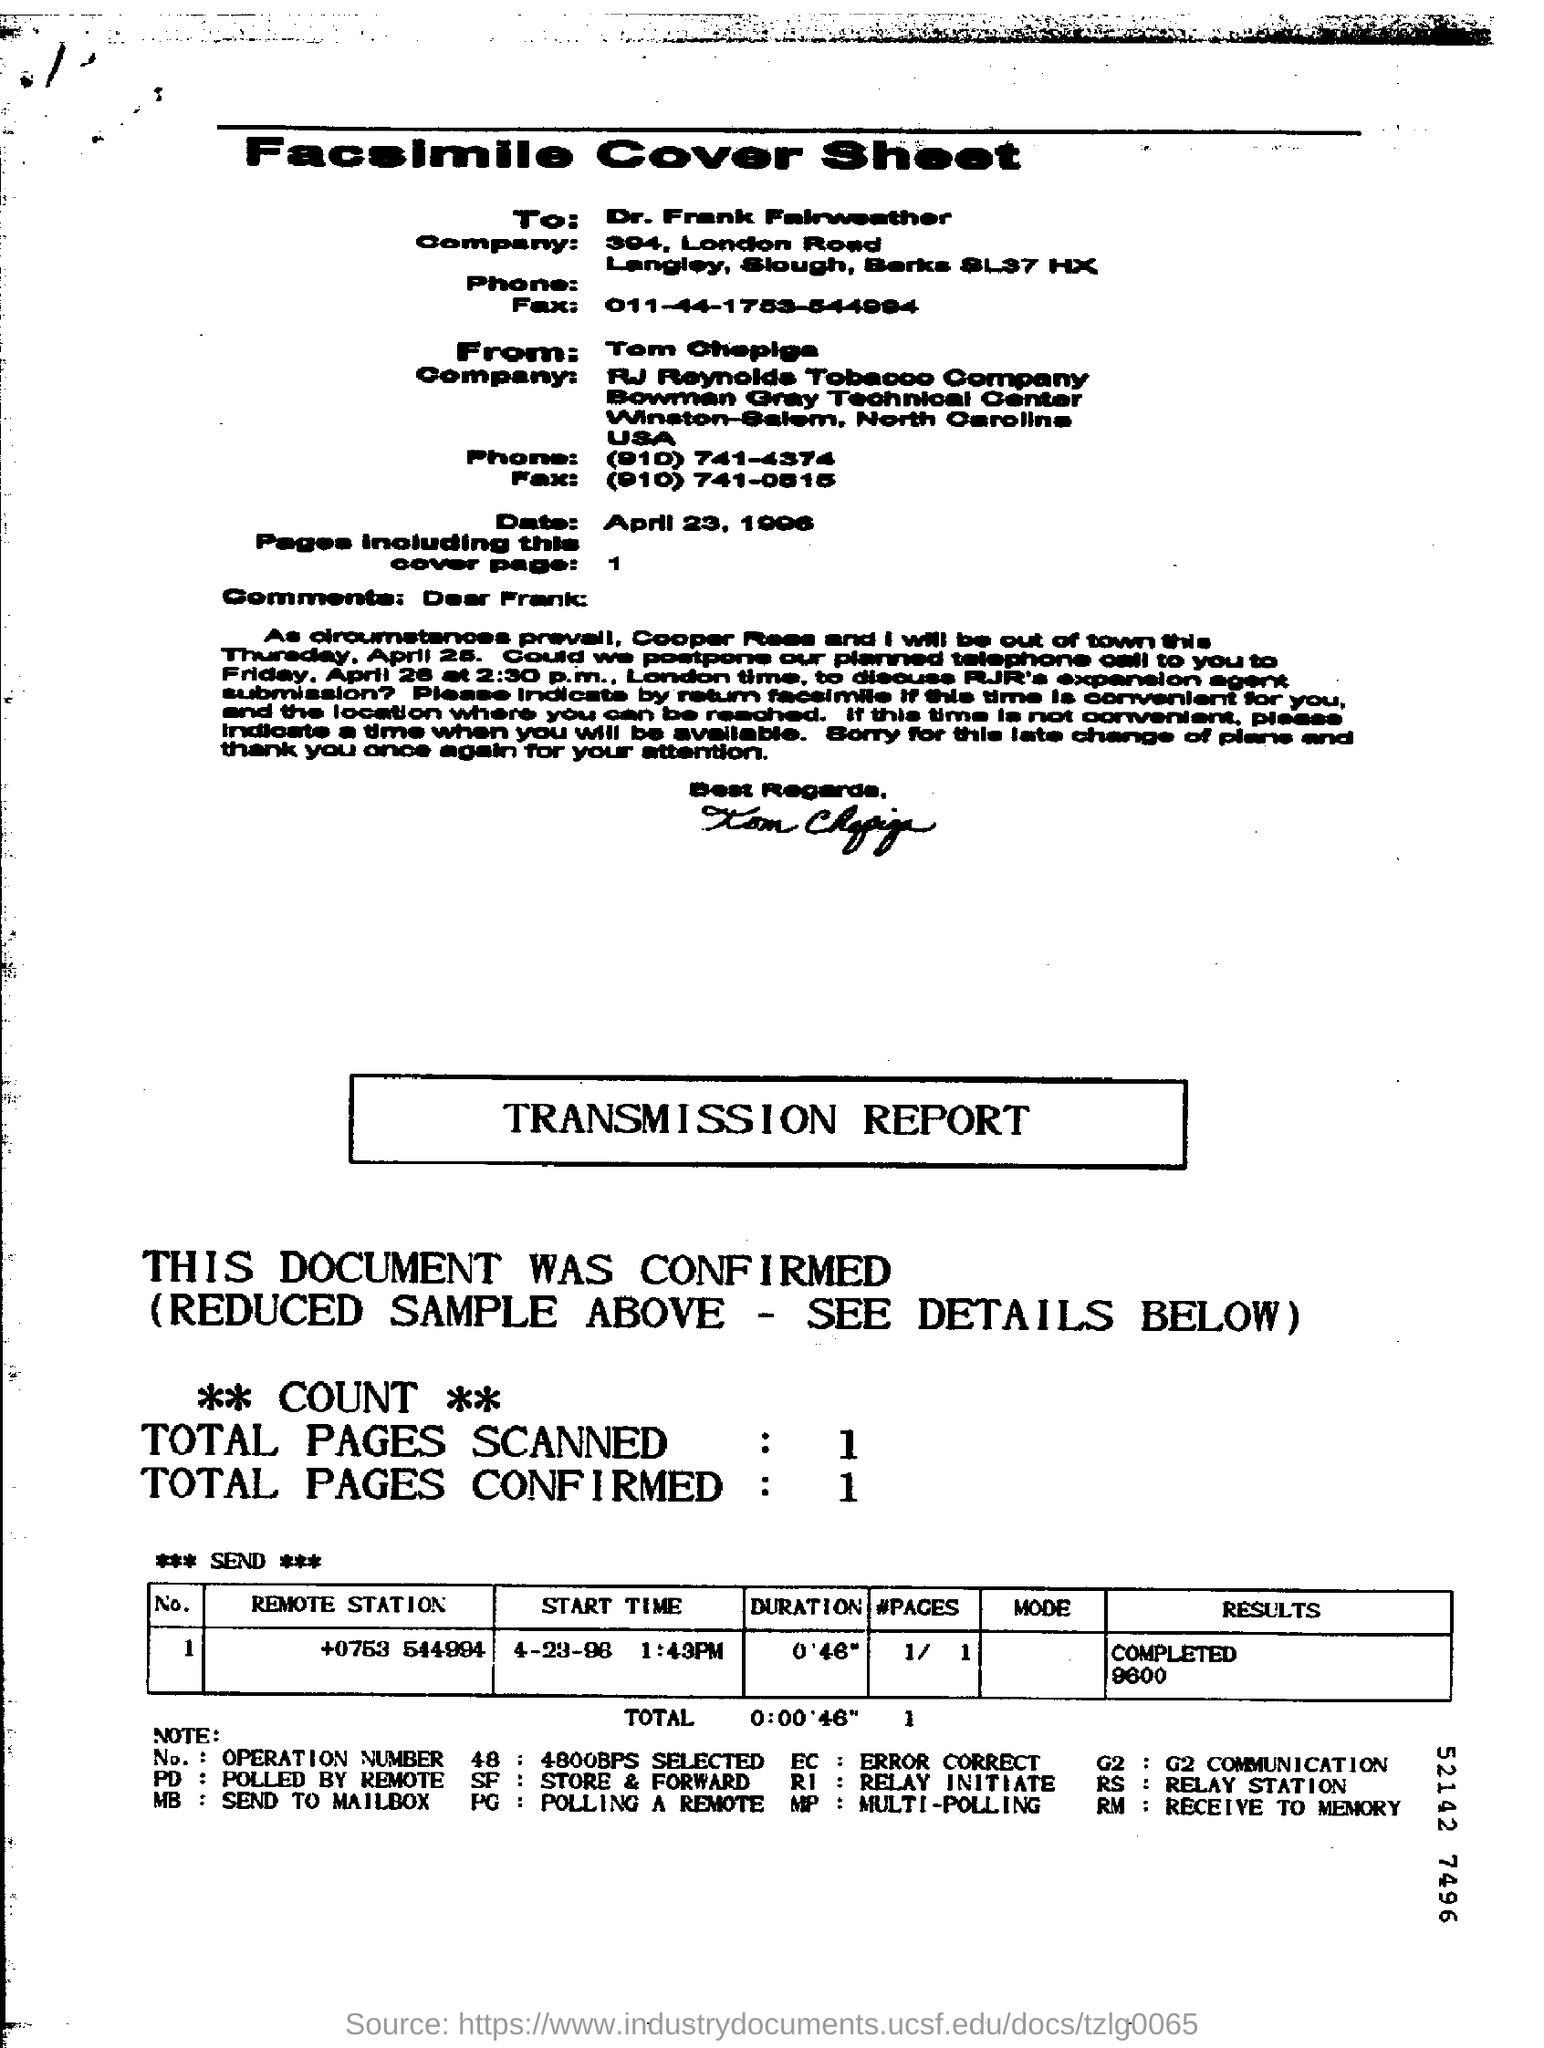Who is the fax addressed to?
Provide a short and direct response. Frank. What is the Fax number of Dr. Frank Fairweather?
Provide a succinct answer. 011-44-1753-544994. What is the remote station number?
Your answer should be compact. +0753 544994. What does RM denote?
Keep it short and to the point. Receive to memory. 